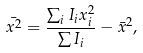<formula> <loc_0><loc_0><loc_500><loc_500>\bar { x ^ { 2 } } = \frac { \sum _ { i } I _ { i } x ^ { 2 } _ { i } } { \sum I _ { i } } - \bar { x } ^ { 2 } ,</formula> 